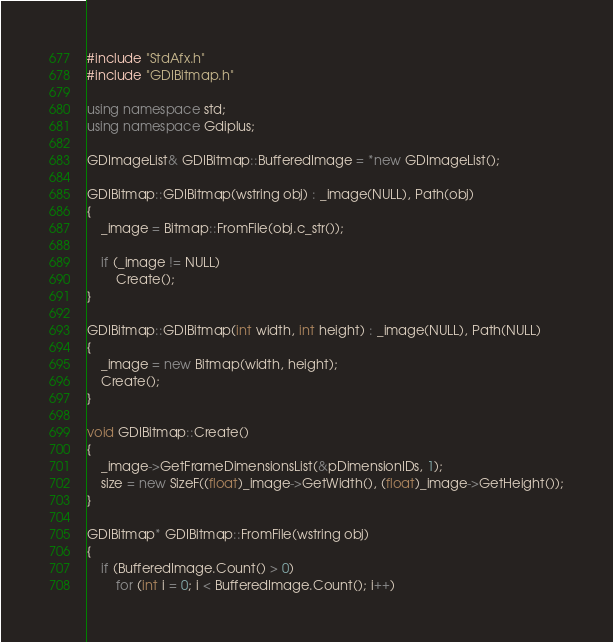Convert code to text. <code><loc_0><loc_0><loc_500><loc_500><_C++_>#include "StdAfx.h"
#include "GDIBitmap.h"

using namespace std;
using namespace Gdiplus;

GDImageList& GDIBitmap::BufferedImage = *new GDImageList();

GDIBitmap::GDIBitmap(wstring obj) : _image(NULL), Path(obj)
{
	_image = Bitmap::FromFile(obj.c_str());

	if (_image != NULL)
		Create();
}

GDIBitmap::GDIBitmap(int width, int height) : _image(NULL), Path(NULL)
{
	_image = new Bitmap(width, height);
	Create();
}

void GDIBitmap::Create()
{
	_image->GetFrameDimensionsList(&pDimensionIDs, 1);
	size = new SizeF((float)_image->GetWidth(), (float)_image->GetHeight());
}

GDIBitmap* GDIBitmap::FromFile(wstring obj)
{
	if (BufferedImage.Count() > 0)
		for (int i = 0; i < BufferedImage.Count(); i++)</code> 